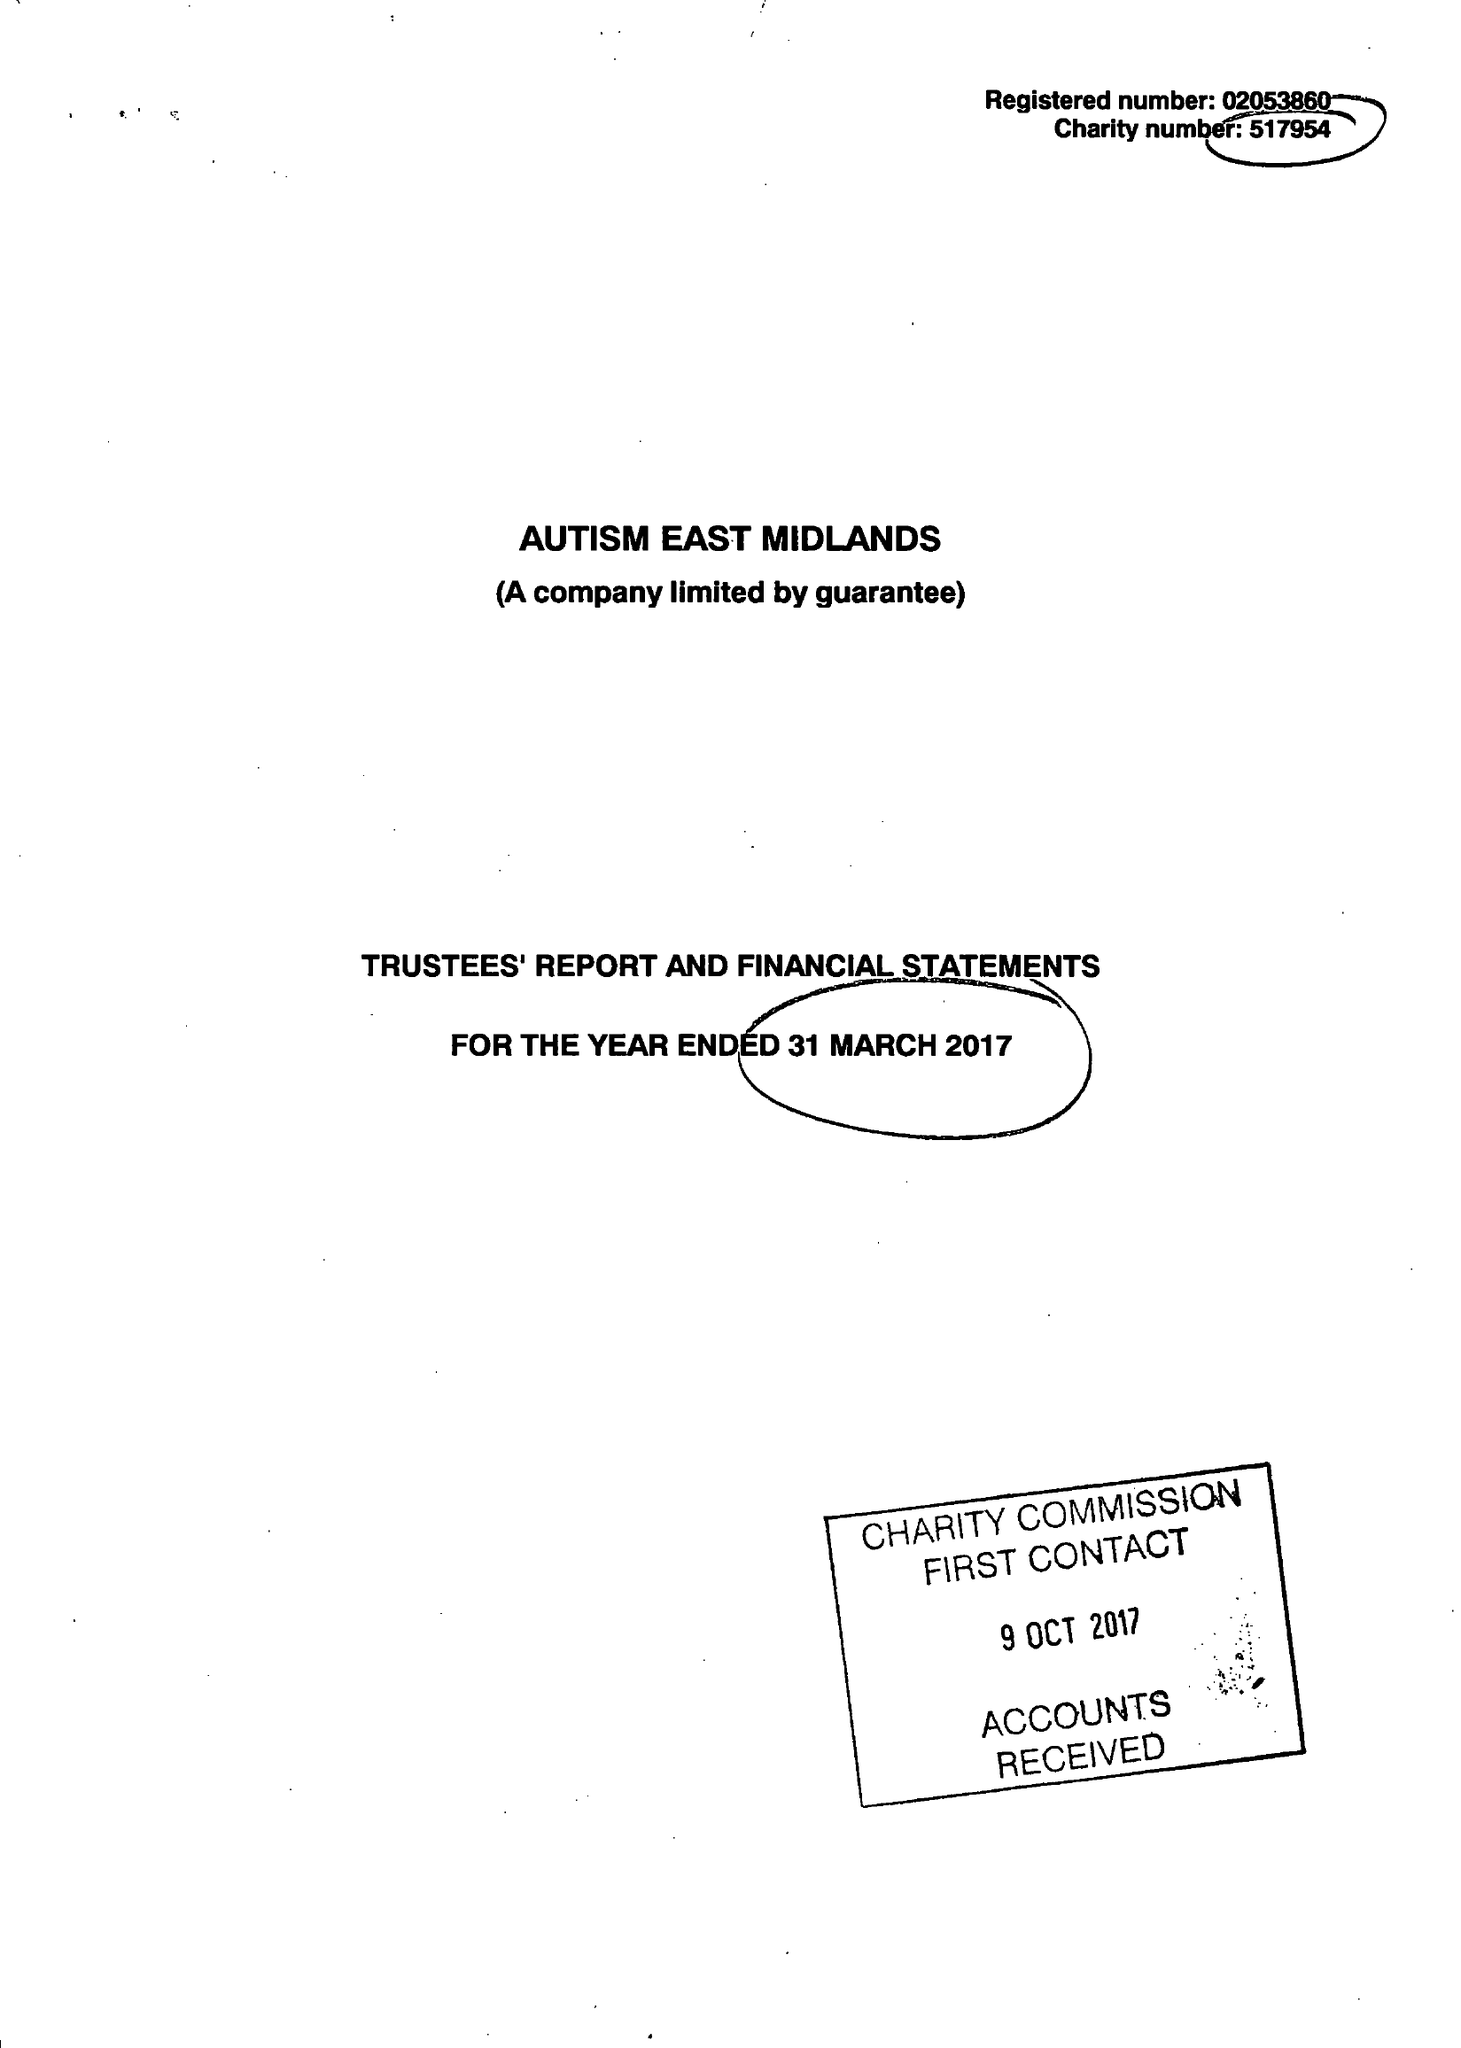What is the value for the address__postcode?
Answer the question using a single word or phrase. S80 4AJ 